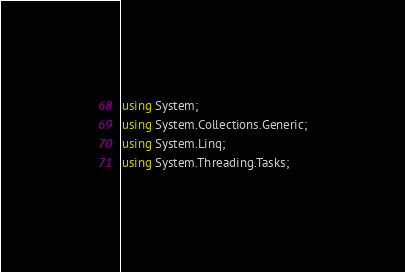<code> <loc_0><loc_0><loc_500><loc_500><_C#_>using System;
using System.Collections.Generic;
using System.Linq;
using System.Threading.Tasks;</code> 